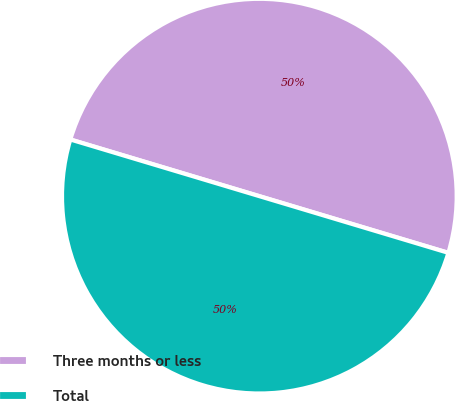Convert chart to OTSL. <chart><loc_0><loc_0><loc_500><loc_500><pie_chart><fcel>Three months or less<fcel>Total<nl><fcel>50.0%<fcel>50.0%<nl></chart> 